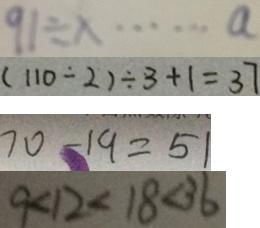<formula> <loc_0><loc_0><loc_500><loc_500>9 1 \div x \cdots a 
 ( 1 1 0 \div 2 ) \div 3 + 1 = 3 7 
 7 0 - 1 9 = 5 1 
 9 < 1 2 < 1 8 < 3 6</formula> 